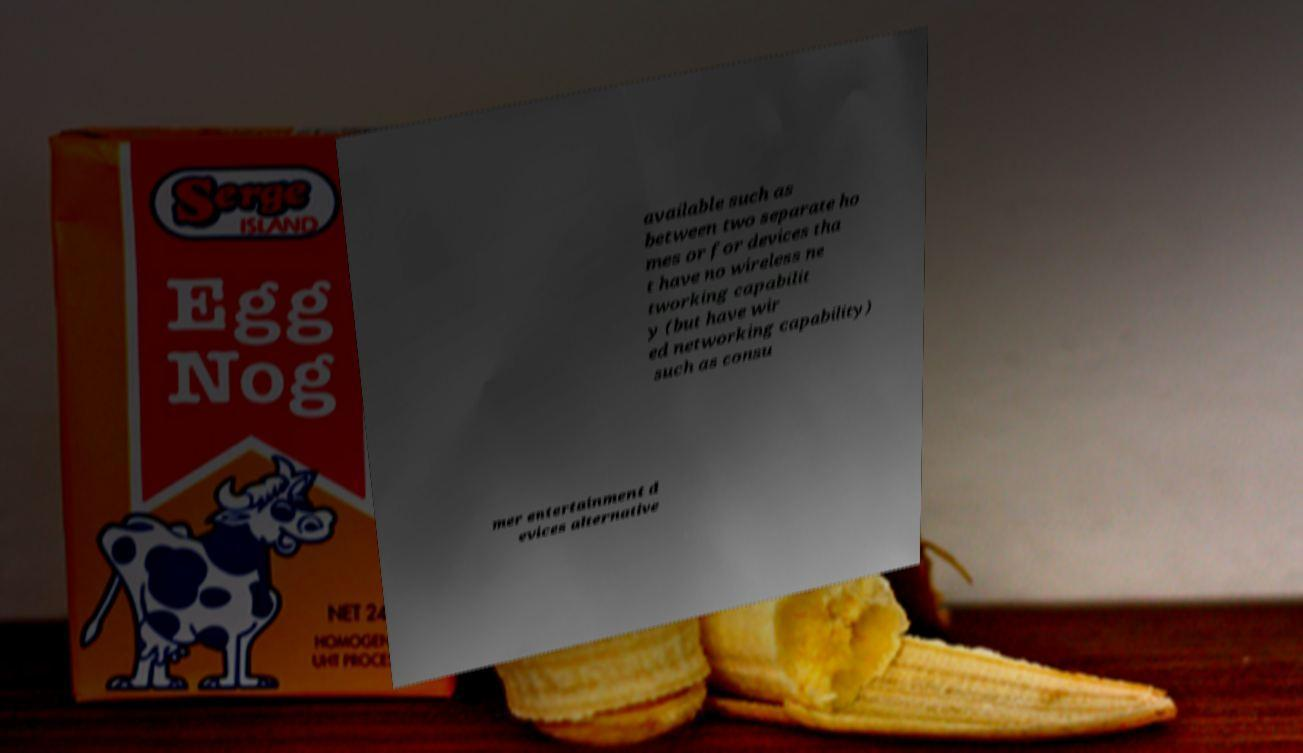For documentation purposes, I need the text within this image transcribed. Could you provide that? available such as between two separate ho mes or for devices tha t have no wireless ne tworking capabilit y (but have wir ed networking capability) such as consu mer entertainment d evices alternative 